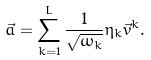Convert formula to latex. <formula><loc_0><loc_0><loc_500><loc_500>\vec { a } = \sum _ { k = 1 } ^ { L } \frac { 1 } { \sqrt { \omega _ { k } } } \eta _ { k } \vec { v } ^ { k } .</formula> 